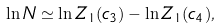<formula> <loc_0><loc_0><loc_500><loc_500>\ln N \simeq \ln Z _ { 1 } ( c _ { 3 } ) - \ln Z _ { 1 } ( c _ { 4 } ) ,</formula> 